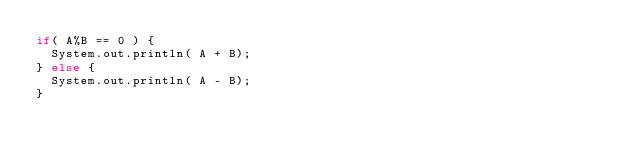<code> <loc_0><loc_0><loc_500><loc_500><_Java_>if( A%B == 0 ) {
  System.out.println( A + B);
} else {
  System.out.println( A - B);
}</code> 